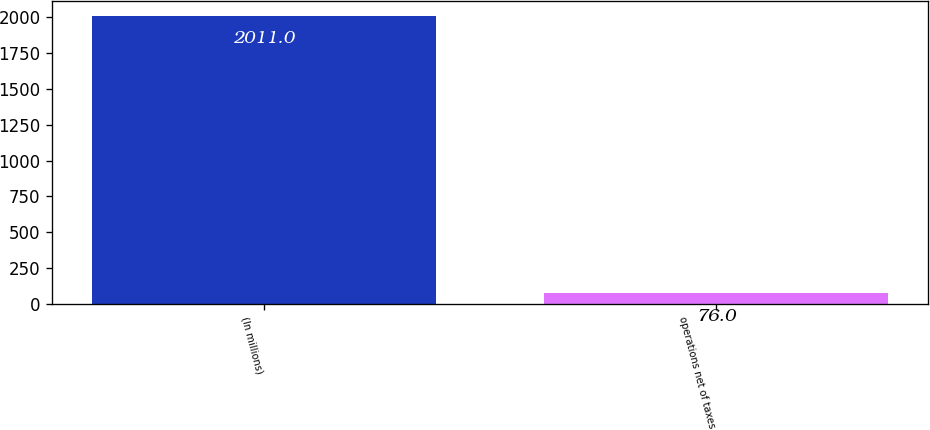Convert chart to OTSL. <chart><loc_0><loc_0><loc_500><loc_500><bar_chart><fcel>(In millions)<fcel>operations net of taxes<nl><fcel>2011<fcel>76<nl></chart> 